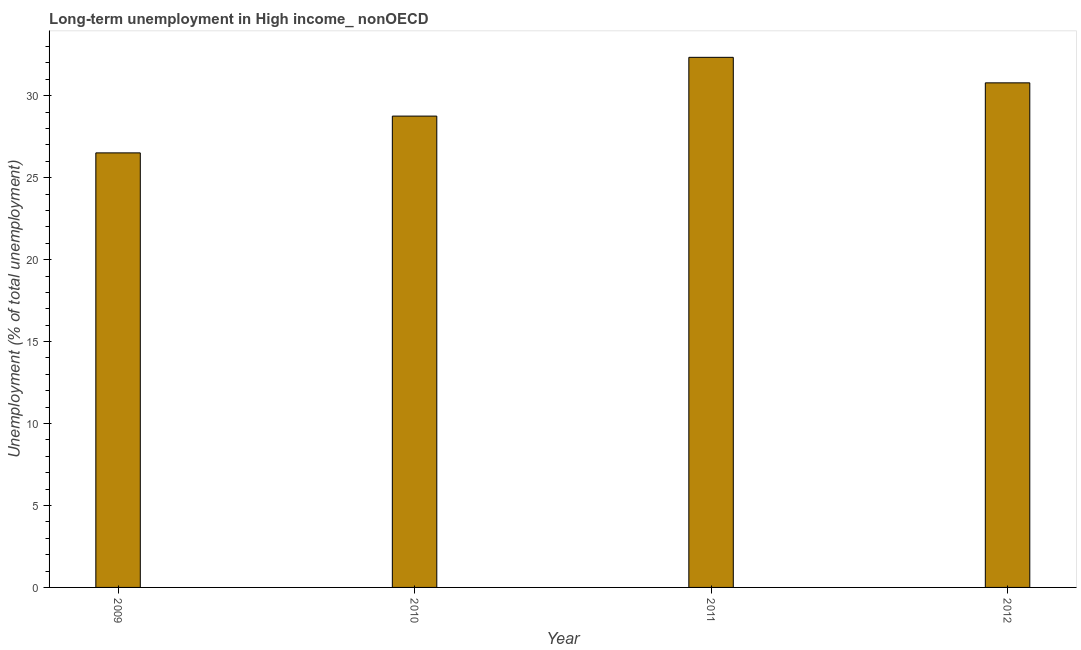Does the graph contain any zero values?
Provide a short and direct response. No. What is the title of the graph?
Offer a terse response. Long-term unemployment in High income_ nonOECD. What is the label or title of the Y-axis?
Make the answer very short. Unemployment (% of total unemployment). What is the long-term unemployment in 2011?
Your answer should be very brief. 32.34. Across all years, what is the maximum long-term unemployment?
Make the answer very short. 32.34. Across all years, what is the minimum long-term unemployment?
Your answer should be compact. 26.51. What is the sum of the long-term unemployment?
Make the answer very short. 118.4. What is the difference between the long-term unemployment in 2009 and 2010?
Provide a succinct answer. -2.25. What is the average long-term unemployment per year?
Keep it short and to the point. 29.6. What is the median long-term unemployment?
Provide a short and direct response. 29.77. In how many years, is the long-term unemployment greater than 10 %?
Give a very brief answer. 4. Do a majority of the years between 2011 and 2010 (inclusive) have long-term unemployment greater than 14 %?
Your response must be concise. No. What is the ratio of the long-term unemployment in 2009 to that in 2012?
Your answer should be very brief. 0.86. Is the difference between the long-term unemployment in 2009 and 2010 greater than the difference between any two years?
Provide a succinct answer. No. What is the difference between the highest and the second highest long-term unemployment?
Your answer should be compact. 1.56. What is the difference between the highest and the lowest long-term unemployment?
Your response must be concise. 5.83. How many years are there in the graph?
Your answer should be compact. 4. What is the Unemployment (% of total unemployment) of 2009?
Provide a succinct answer. 26.51. What is the Unemployment (% of total unemployment) in 2010?
Offer a very short reply. 28.76. What is the Unemployment (% of total unemployment) in 2011?
Your answer should be very brief. 32.34. What is the Unemployment (% of total unemployment) of 2012?
Your answer should be very brief. 30.78. What is the difference between the Unemployment (% of total unemployment) in 2009 and 2010?
Provide a succinct answer. -2.24. What is the difference between the Unemployment (% of total unemployment) in 2009 and 2011?
Give a very brief answer. -5.83. What is the difference between the Unemployment (% of total unemployment) in 2009 and 2012?
Make the answer very short. -4.27. What is the difference between the Unemployment (% of total unemployment) in 2010 and 2011?
Give a very brief answer. -3.59. What is the difference between the Unemployment (% of total unemployment) in 2010 and 2012?
Your answer should be compact. -2.03. What is the difference between the Unemployment (% of total unemployment) in 2011 and 2012?
Offer a very short reply. 1.56. What is the ratio of the Unemployment (% of total unemployment) in 2009 to that in 2010?
Your answer should be compact. 0.92. What is the ratio of the Unemployment (% of total unemployment) in 2009 to that in 2011?
Your answer should be very brief. 0.82. What is the ratio of the Unemployment (% of total unemployment) in 2009 to that in 2012?
Keep it short and to the point. 0.86. What is the ratio of the Unemployment (% of total unemployment) in 2010 to that in 2011?
Your answer should be compact. 0.89. What is the ratio of the Unemployment (% of total unemployment) in 2010 to that in 2012?
Your answer should be very brief. 0.93. What is the ratio of the Unemployment (% of total unemployment) in 2011 to that in 2012?
Offer a terse response. 1.05. 